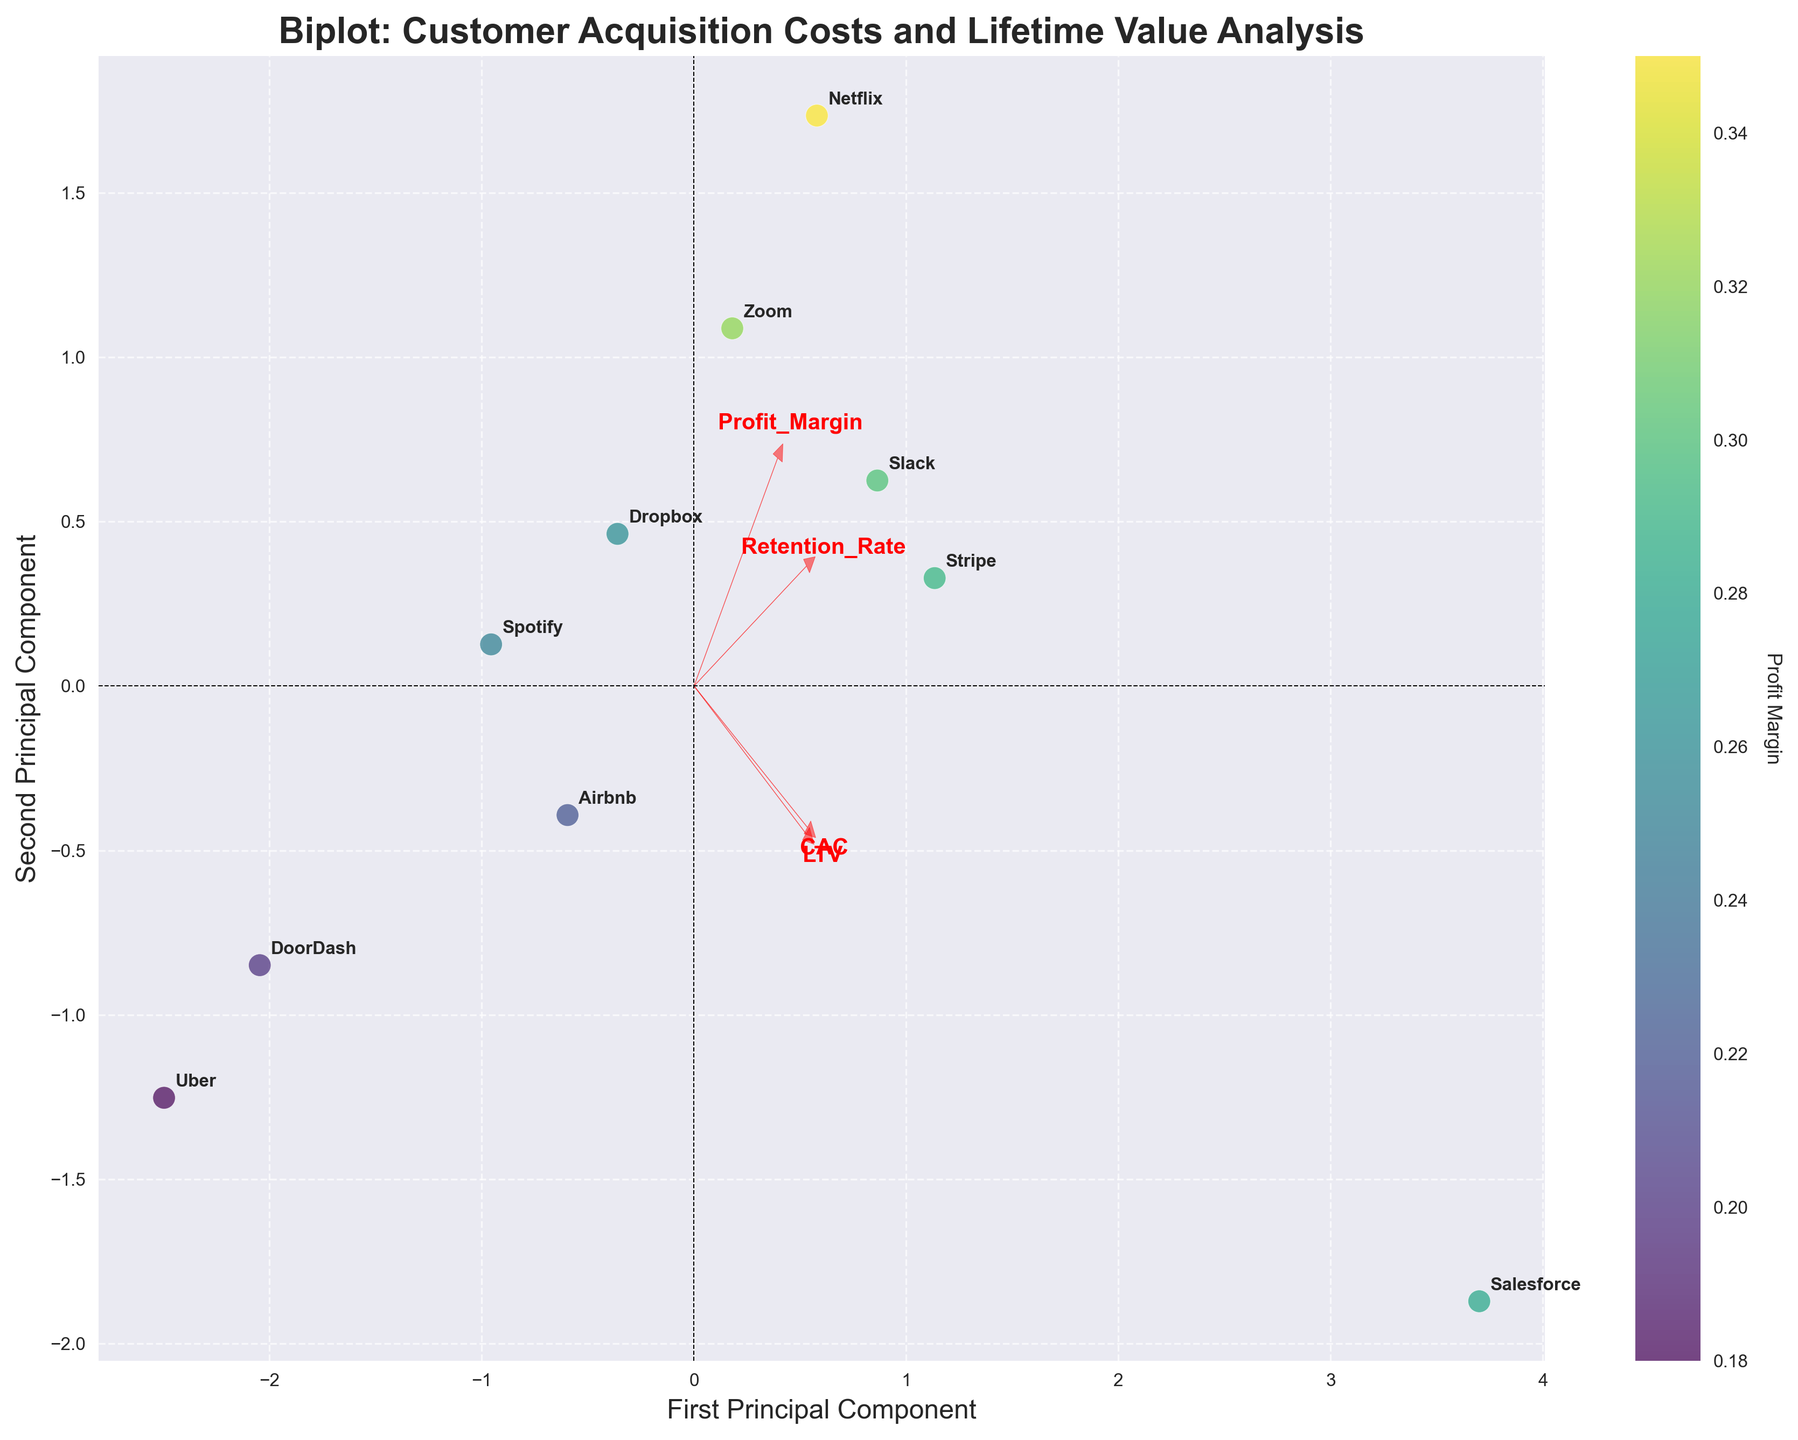What is the title of the plot? The title of the plot can be found at the top of the figure, indicating what the plot is about.
Answer: Biplot: Customer Acquisition Costs and Lifetime Value Analysis How many data points are shown on the biplot? The data points correspond to the companies listed in the dataset and are visually represented on the biplot as scattered points.
Answer: 10 Which company has the highest first principal component value? The first principal component value is represented on the x-axis. By identifying the point furthest to the right, we can determine which company has the highest value.
Answer: Salesforce Which feature vector points in the same direction as the second principal component? The second principal component is represented on the y-axis. By examining the orientation of the feature vectors (red arrows), we can determine which features align predominantly with the y-axis.
Answer: Retention_Rate Explain the relationship between `CAC` and `Profit Margin` as shown in the biplot. In the biplot, you observe the direction of the `CAC` vector relative to the `Profit Margin` color gradient. Features pointing similarly can indicate a positive correlation, while opposite directions show a negative correlation. `CAC` and `Profit Margin` have vectors pointing in different directions showing a negative correlation—their relationship is inversely proportional.
Answer: Inversely proportional Which features seem to contribute most to the first principal component? The features contributing most to a principal component are represented by the arrow lengths in that direction. By looking at the arrows oriented primarily along the first principal component (x-axis), we can determine their relative contribution.
Answer: CAC and LTV What company has the lowest profit margin and how do you identify it in the biplot? The profit margin is indicated by the color gradient. The company with the lowest profit margin would correspond to the point with the lightest color, which indicates the lowest value on the viridis color scale.
Answer: Uber Between `Retention_Rate` and `LTV`, which has a stronger influence on the second principal component? To determine which feature has a stronger influence on the second principal component (y-axis), we compare the length and direction of the vectors. The longer the vector along the y-axis, the stronger its influence.
Answer: Retention_Rate What is the main insight derived from the relationship between `CAC` and `LTV` as visualized in the plot? The biplot shows the directional vectors of `CAC` and `LTV`. By examining these vectors’ angles and lengths, we can interpret the relationship. Since these vectors point in similar directions with moderate length, it suggests that `CAC` and `LTV` are relatively correlated.
Answer: They are positively correlated What does the relative positioning of Airbnb and Stripe indicate about their `CAC`, `LTV`, `Retention_Rate`, and `Profit_Margin`? By examining the company positions and their distances relative to the feature vectors, you can infer specifics about their metrics. Closer positions mean more similarity in the principal component space. Stripe, further along the vector directions for `LTV`, `Retention_Rate`, and `Profit_Margin`, suggests higher values in these features compared to Airbnb. However, Airbnb has a significantly lower `CAC`.
Answer: Stripe has higher `LTV`, `Retention_Rate`, and `Profit_Margin`, lower `CAC` compared to Airbnb 